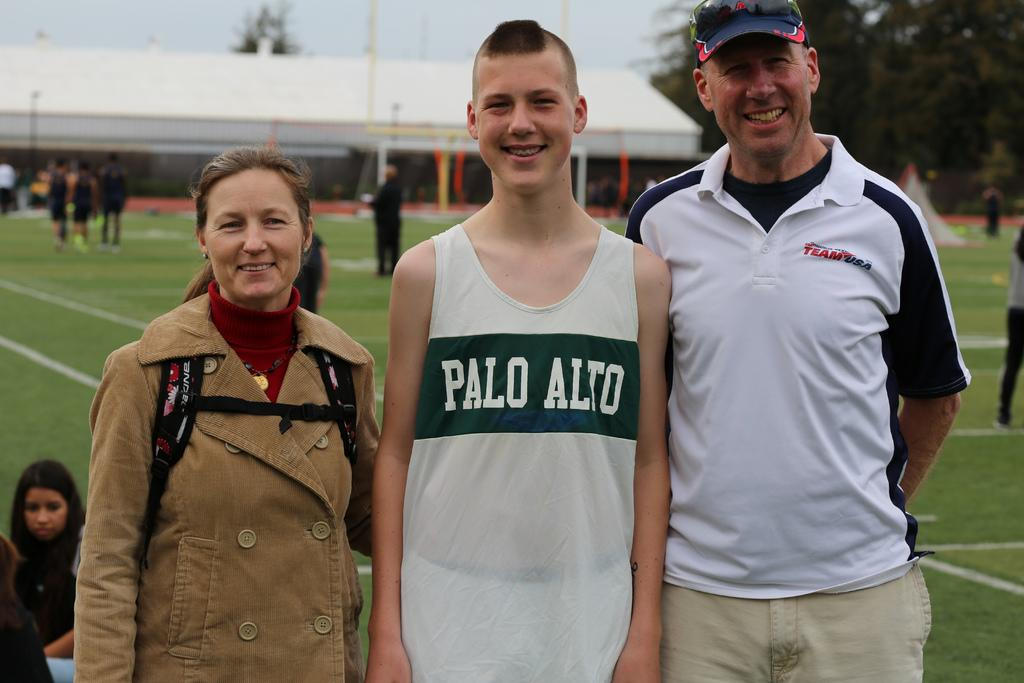<image>
Provide a brief description of the given image. A boy wearing a Palo Alto Jersey stands with his parents and smiles 